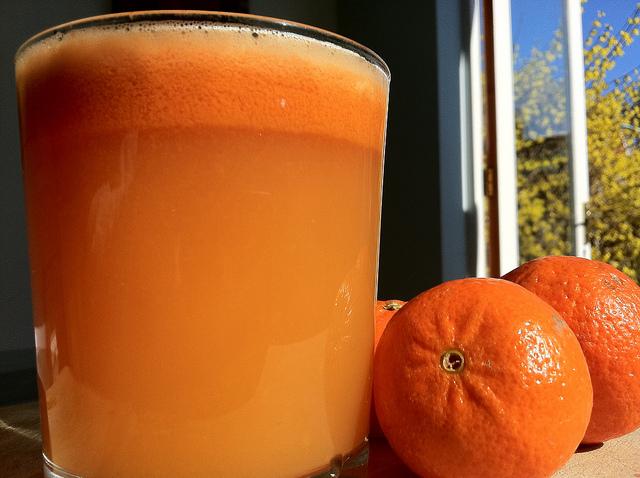What causes the water droplets in the container?
Quick response, please. Condensation. Where does this fruit grow?
Give a very brief answer. Florida. Is the juice in the cup from the organs?
Short answer required. Yes. Which of these would a rabbit like the most?
Quick response, please. Orange. Is the liquid in the clear container the same shade as the oranges?
Quick response, please. Yes. 